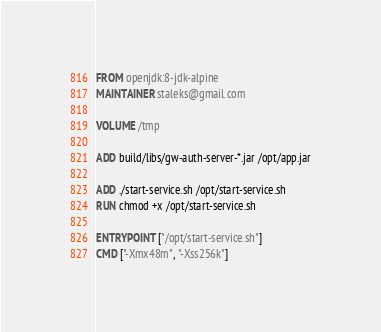Convert code to text. <code><loc_0><loc_0><loc_500><loc_500><_Dockerfile_>FROM openjdk:8-jdk-alpine
MAINTAINER staleks@gmail.com

VOLUME /tmp

ADD build/libs/gw-auth-server-*.jar /opt/app.jar

ADD ./start-service.sh /opt/start-service.sh
RUN chmod +x /opt/start-service.sh

ENTRYPOINT ["/opt/start-service.sh"]
CMD ["-Xmx48m", "-Xss256k"]

</code> 